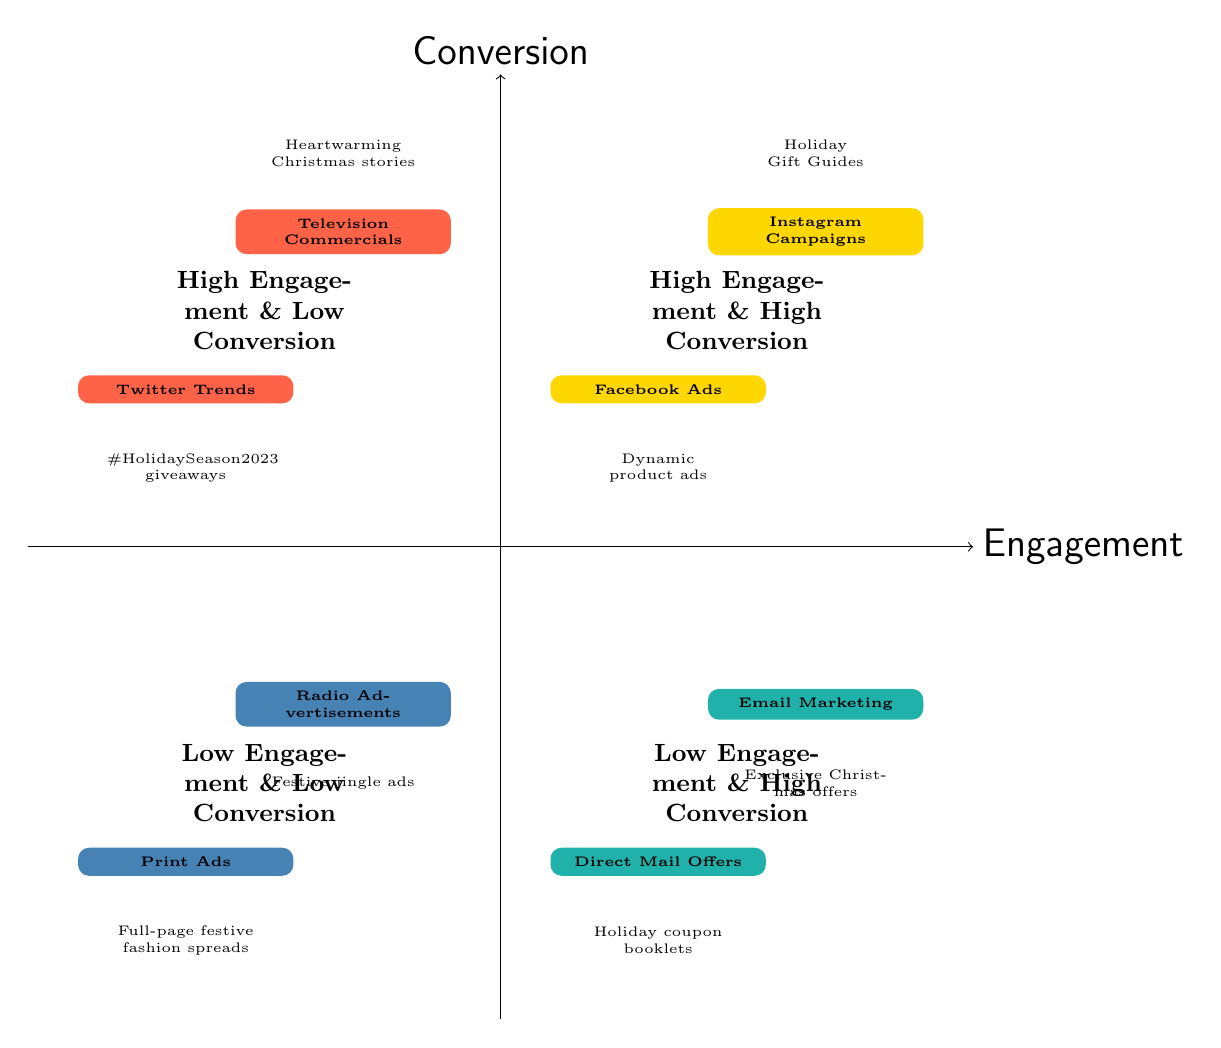What are the two media types in the High Engagement & High Conversion quadrant? The High Engagement & High Conversion quadrant contains Instagram Campaigns and Facebook Ads. This can be determined by locating that specific quadrant in the diagram and identifying the nodes listed within it.
Answer: Instagram Campaigns, Facebook Ads How many nodes are there in the Low Engagement & Low Conversion quadrant? The Low Engagement & Low Conversion quadrant contains two nodes: Radio Advertisements and Print Ads. The number of nodes is simply counted by looking at the entries in that quadrant of the diagram.
Answer: 2 Which campaign is an example of High Engagement & Low Conversion? The High Engagement & Low Conversion quadrant includes Television Commercials and Twitter Trends. These are the examples provided in that specific quadrant of the diagram.
Answer: Television Commercials What is the main characteristic of Email Marketing as displayed in the diagram? Email Marketing is positioned in the Low Engagement & High Conversion quadrant, indicating that it delivers high conversion rates despite lower engagement. This information is gathered from its placement in the quadrant and the accompanying description.
Answer: Low Engagement & High Conversion Which campaign is associated with the example "Exclusive Christmas offers to loyalty program members"? This example corresponds to Email Marketing, which is located in the Low Engagement & High Conversion quadrant. The example clearly denotes what Email Marketing offers, providing a direct connection to the campaign type.
Answer: Email Marketing In which quadrant do we find Twitter Trends, and what does it indicate about its performance? Twitter Trends is located in the High Engagement & Low Conversion quadrant, indicating that while it generates significant engagement, it does not lead to high sales conversions. This is confirmed by its position and the description provided for that quadrant.
Answer: High Engagement & Low Conversion What type of media is primarily used in the Low Engagement & High Conversion quadrant? The Low Engagement & High Conversion quadrant primarily features digital and direct marketing media, specifically Email Marketing and Direct Mail Offers, which focus on direct conversions with lower engagement metrics. This can be discerned from the quadrant's label and the types of campaigns listed.
Answer: Email Marketing, Direct Mail Offers 